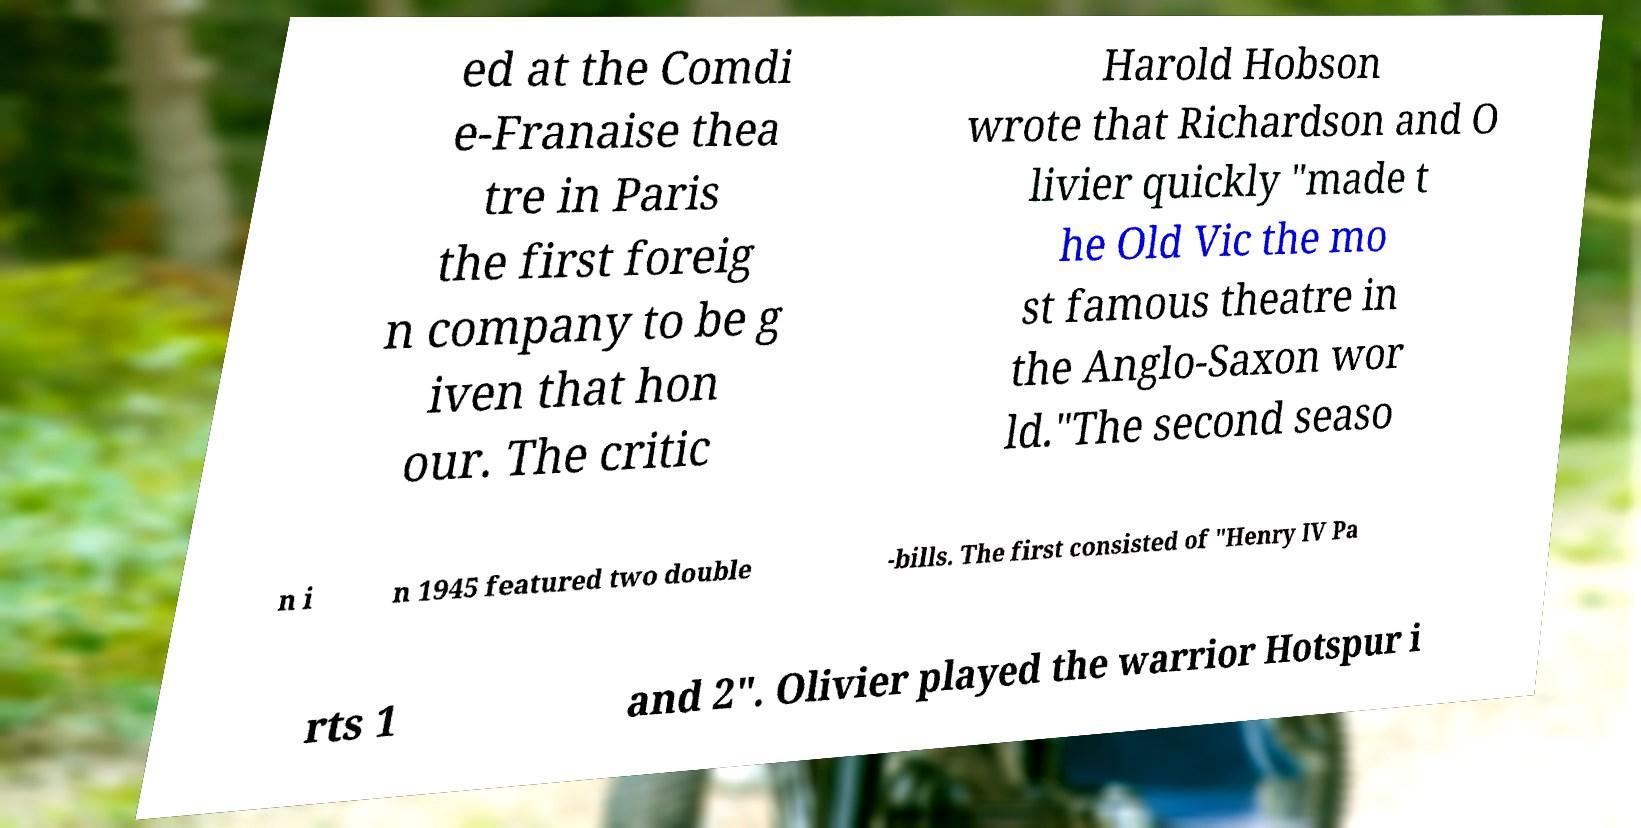Please read and relay the text visible in this image. What does it say? ed at the Comdi e-Franaise thea tre in Paris the first foreig n company to be g iven that hon our. The critic Harold Hobson wrote that Richardson and O livier quickly "made t he Old Vic the mo st famous theatre in the Anglo-Saxon wor ld."The second seaso n i n 1945 featured two double -bills. The first consisted of "Henry IV Pa rts 1 and 2". Olivier played the warrior Hotspur i 